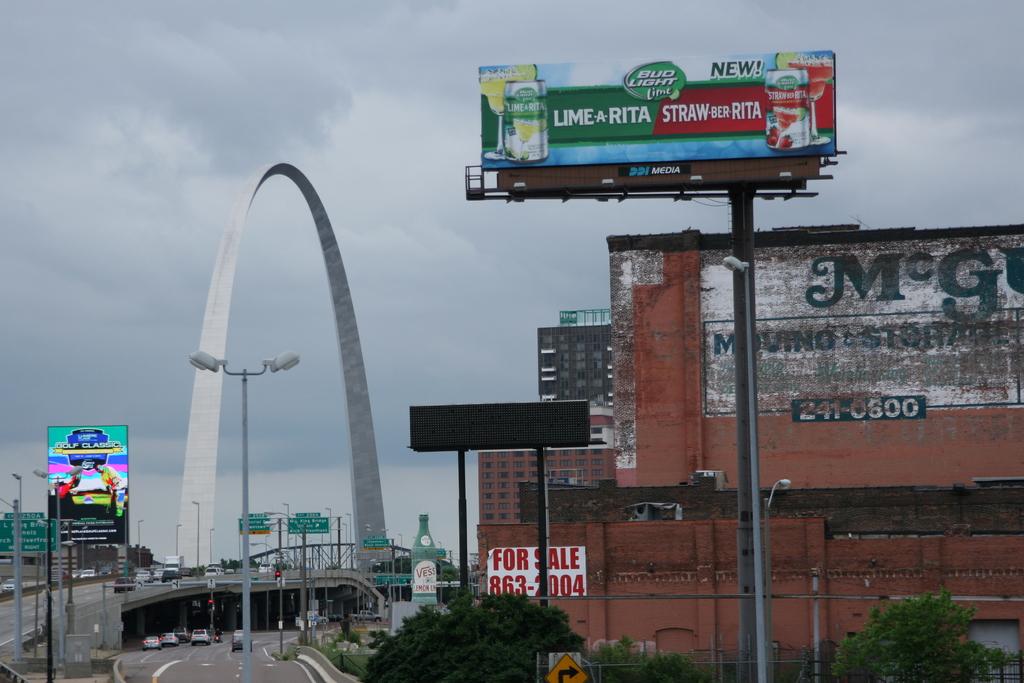What is written on the white and red sign on the building?
Offer a terse response. For sale. 